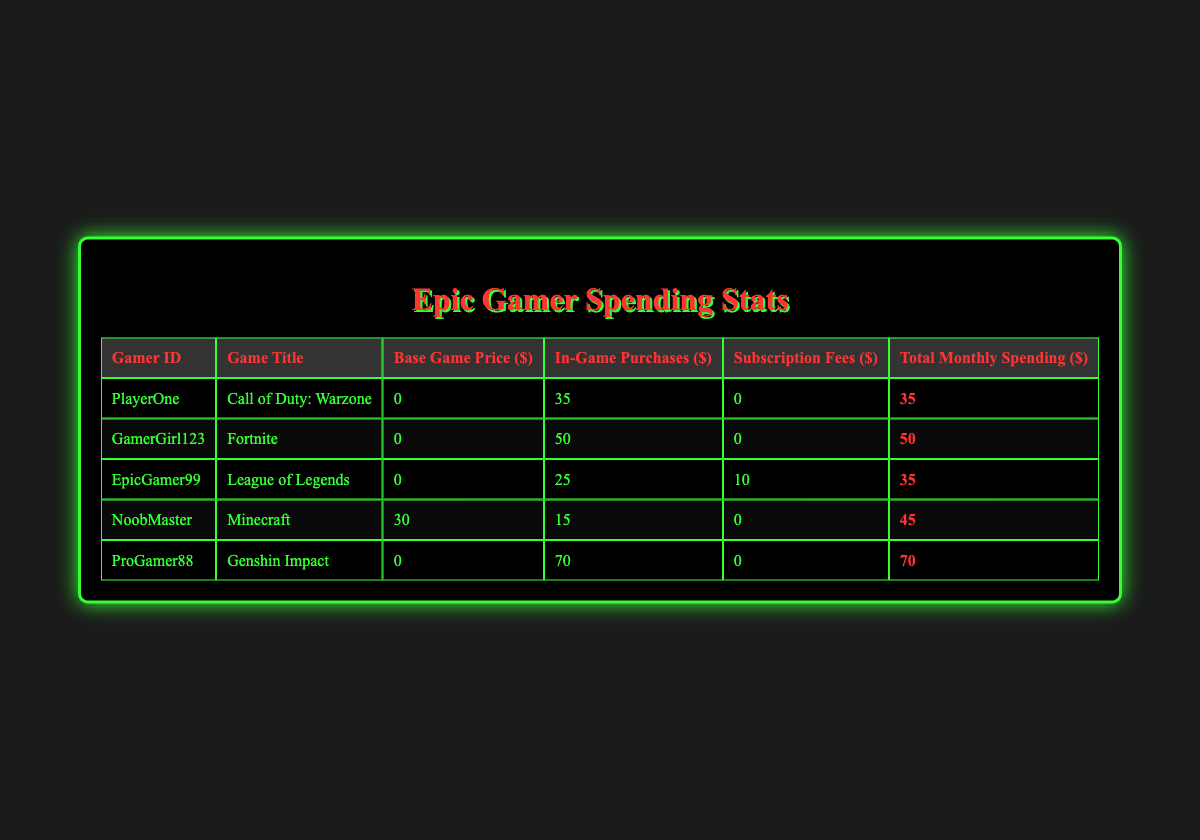What is the total monthly spending for ProGamer88? In the table, locate the row for ProGamer88, where the Total Monthly Spending is listed. It shows a value of 70.
Answer: 70 Which game has the highest in-game purchases? Check each row's In-Game Purchases column and compare the values. The highest value is 70 for Genshin Impact (by ProGamer88).
Answer: Genshin Impact How much did EpicGamer99 spend on subscriptions? Look for the row corresponding to EpicGamer99 and check the Subscription Fees column, which shows 10.
Answer: 10 What is the average total monthly spending of all gamers? To find the average, sum all Total Monthly Spending values (35 + 50 + 35 + 45 + 70 = 235) and divide by the number of gamers (5). Thus, the average is 235/5 = 47.
Answer: 47 Did any gamer spend more than 60 dollars in total monthly spending? Review the Total Monthly Spending column for values greater than 60. Only ProGamer88 spent 70, which is more than 60.
Answer: Yes What is the difference in total spending between the gamer with the highest and lowest spending? Identify the maximum Total Monthly Spending (70 from ProGamer88) and the minimum (35 from PlayerOne and EpicGamer99). The difference is 70 - 35 = 35.
Answer: 35 How many gamers have a total monthly spending of 35 dollars? Check the Total Monthly Spending column for the number of gamers who spent 35. Both PlayerOne and EpicGamer99 spent this amount, so there are 2 gamers.
Answer: 2 If you combined the in-game purchases from NoobMaster and EpicGamer99, how much would it be? Look at the In-Game Purchases for NoobMaster (15) and EpicGamer99 (25) and add them together: 15 + 25 = 40.
Answer: 40 Is it true that all gamers spent less than 100 dollars on in-game purchases? Review the In-Game Purchases for each gamer. The maximum is 70 from ProGamer88, which is less than 100, confirming that the statement is true.
Answer: Yes 